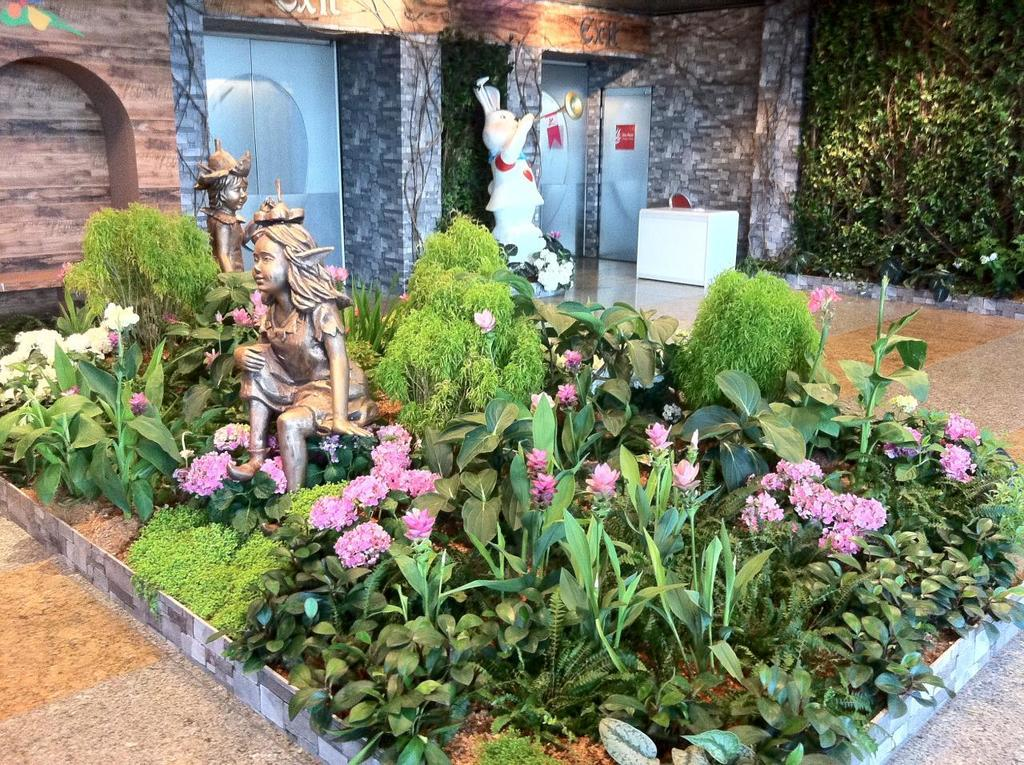What type of plants can be seen in the image? There are plants with flowers in the image. What other objects are present in the image besides plants? There are sculptures, a table, a chair, and doors in the image. Can you describe the table in the image? There is a table in the image, but its specific characteristics are not mentioned in the facts. How many doors are visible in the image? The facts do not specify the number of doors in the image. Can you see any pigs swimming in the ocean in the image? There is no ocean or pigs present in the image; it features plants with flowers, sculptures, a table, a chair, and doors. 